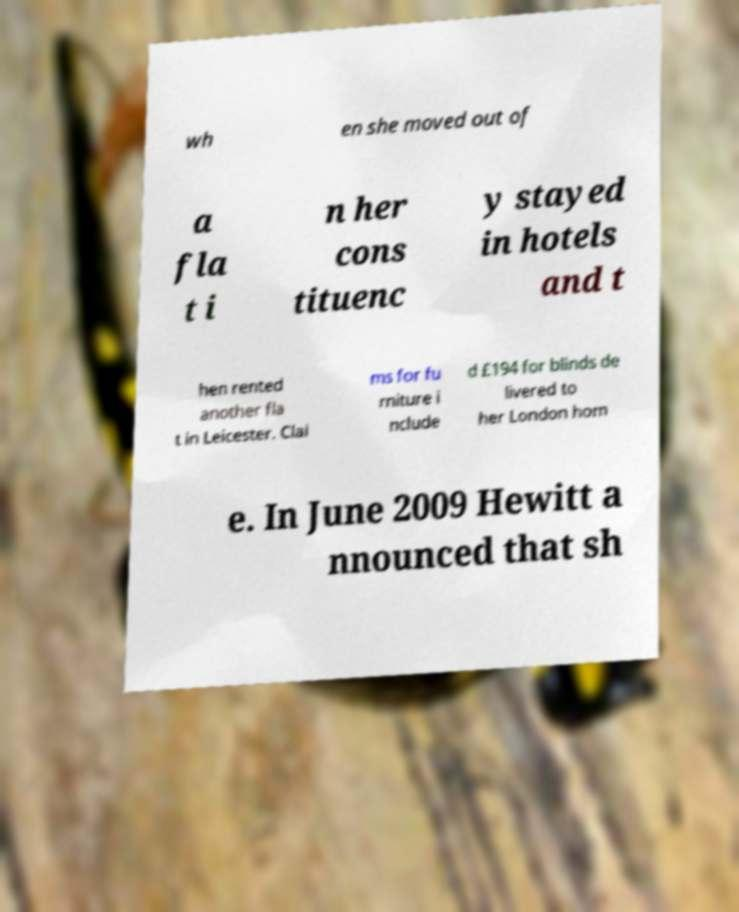Could you assist in decoding the text presented in this image and type it out clearly? wh en she moved out of a fla t i n her cons tituenc y stayed in hotels and t hen rented another fla t in Leicester. Clai ms for fu rniture i nclude d £194 for blinds de livered to her London hom e. In June 2009 Hewitt a nnounced that sh 